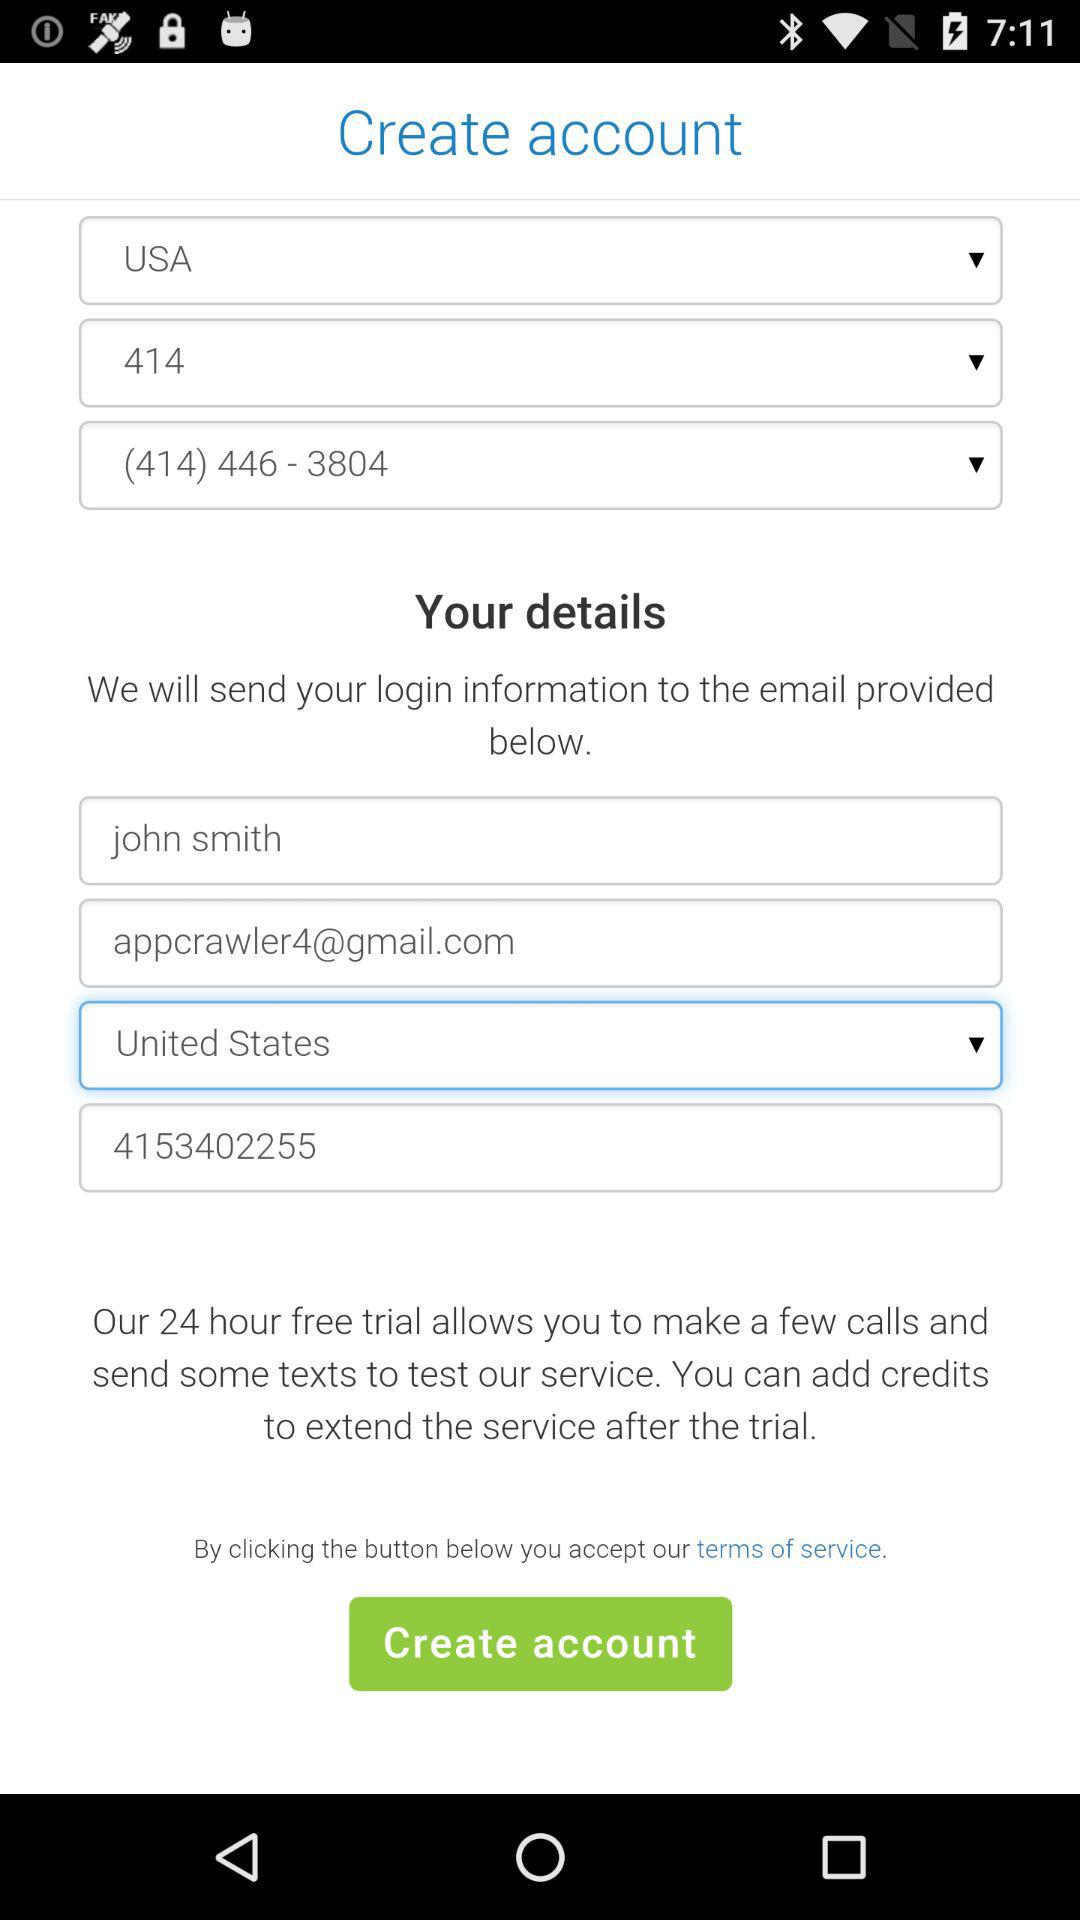What is the phone number? The phone numbers are (414) 446-3804 and 4153402255. 